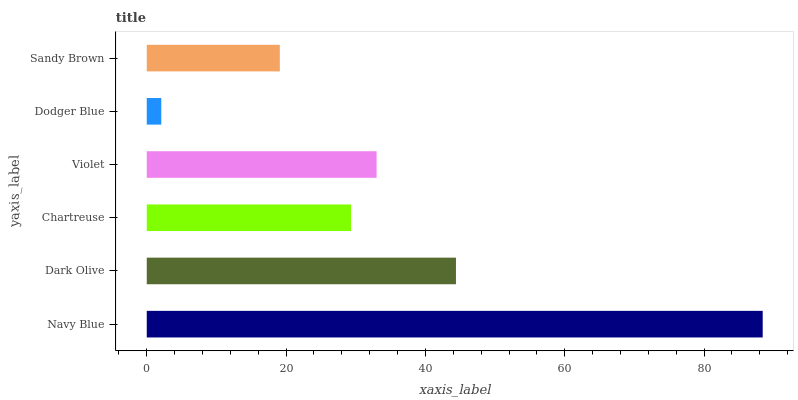Is Dodger Blue the minimum?
Answer yes or no. Yes. Is Navy Blue the maximum?
Answer yes or no. Yes. Is Dark Olive the minimum?
Answer yes or no. No. Is Dark Olive the maximum?
Answer yes or no. No. Is Navy Blue greater than Dark Olive?
Answer yes or no. Yes. Is Dark Olive less than Navy Blue?
Answer yes or no. Yes. Is Dark Olive greater than Navy Blue?
Answer yes or no. No. Is Navy Blue less than Dark Olive?
Answer yes or no. No. Is Violet the high median?
Answer yes or no. Yes. Is Chartreuse the low median?
Answer yes or no. Yes. Is Dark Olive the high median?
Answer yes or no. No. Is Dodger Blue the low median?
Answer yes or no. No. 